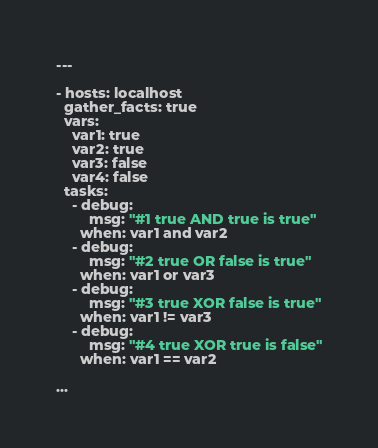<code> <loc_0><loc_0><loc_500><loc_500><_YAML_>---

- hosts: localhost
  gather_facts: true
  vars:
    var1: true
    var2: true
    var3: false
    var4: false
  tasks:
    - debug:
        msg: "#1 true AND true is true"
      when: var1 and var2
    - debug:
        msg: "#2 true OR false is true"
      when: var1 or var3
    - debug:
        msg: "#3 true XOR false is true"
      when: var1 != var3
    - debug:
        msg: "#4 true XOR true is false"
      when: var1 == var2

...
</code> 